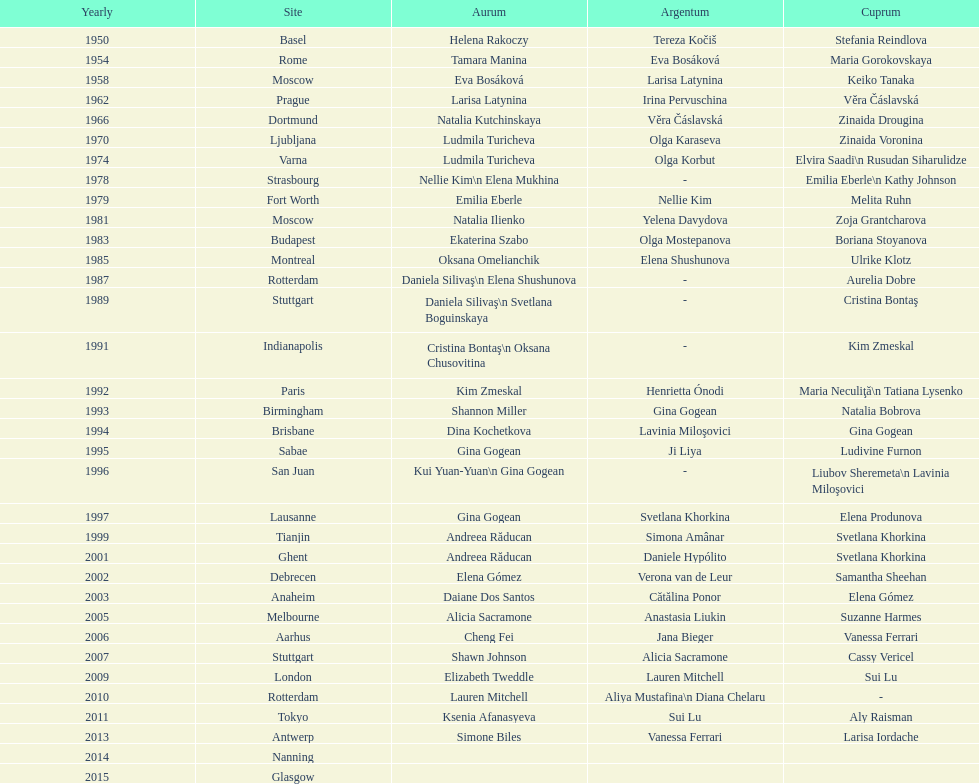How many consecutive floor exercise gold medals did romanian star andreea raducan win at the world championships? 2. 